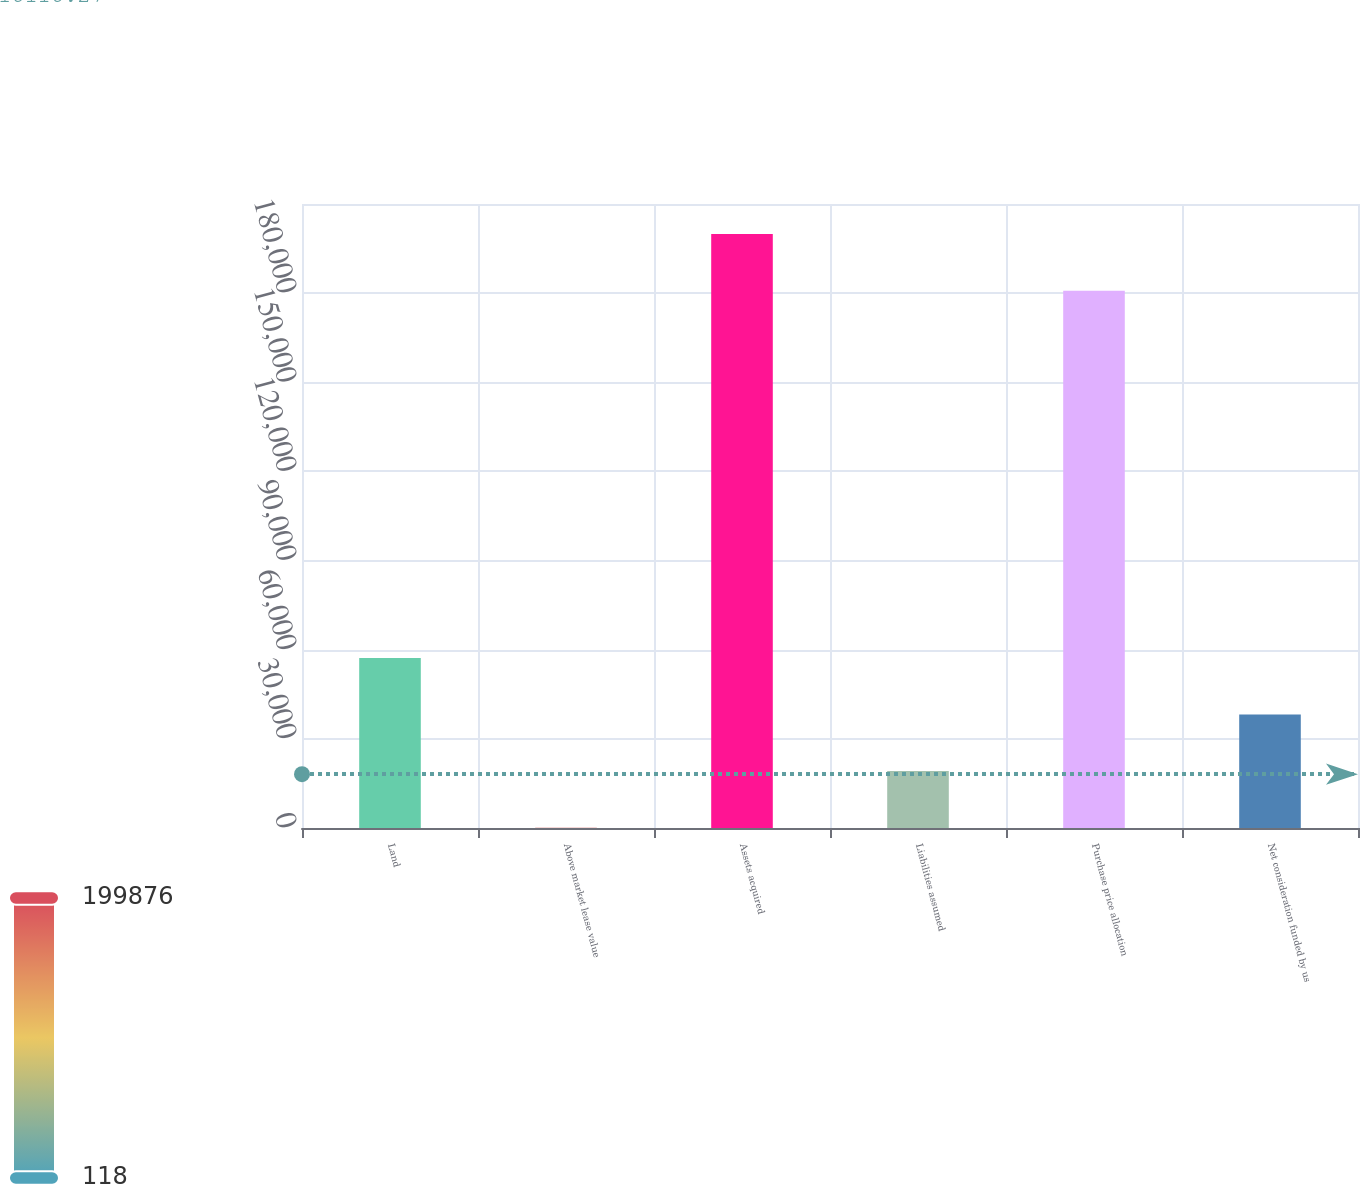Convert chart. <chart><loc_0><loc_0><loc_500><loc_500><bar_chart><fcel>Land<fcel>Above market lease value<fcel>Assets acquired<fcel>Liabilities assumed<fcel>Purchase price allocation<fcel>Net consideration funded by us<nl><fcel>57242.5<fcel>118<fcel>199876<fcel>19159.5<fcel>180834<fcel>38201<nl></chart> 